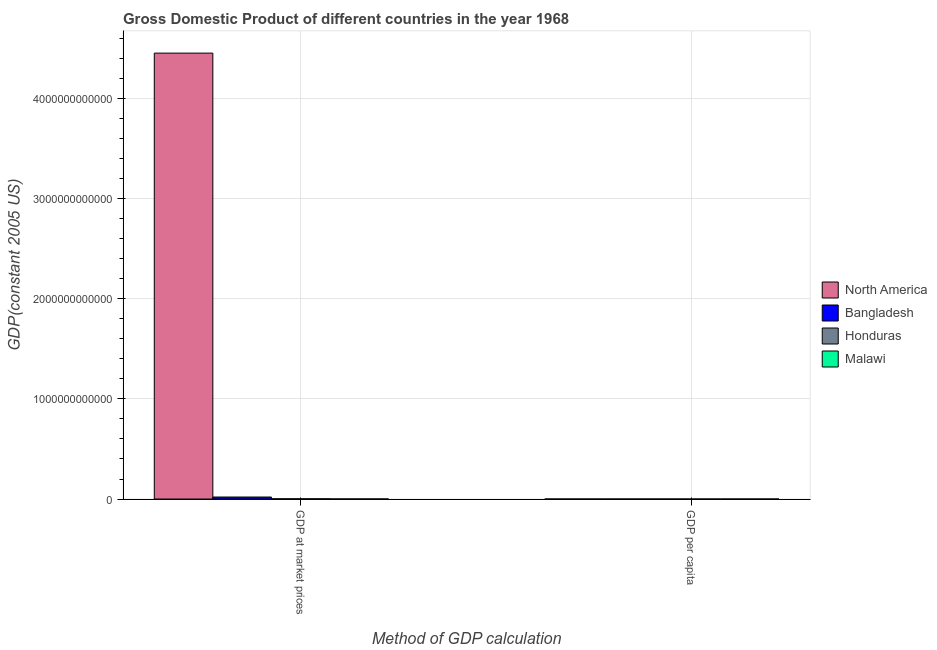How many different coloured bars are there?
Your response must be concise. 4. Are the number of bars on each tick of the X-axis equal?
Your answer should be very brief. Yes. How many bars are there on the 2nd tick from the left?
Your response must be concise. 4. What is the label of the 1st group of bars from the left?
Provide a short and direct response. GDP at market prices. What is the gdp at market prices in Bangladesh?
Your answer should be compact. 2.00e+1. Across all countries, what is the maximum gdp at market prices?
Provide a succinct answer. 4.46e+12. Across all countries, what is the minimum gdp per capita?
Your answer should be very brief. 169.82. In which country was the gdp per capita maximum?
Your response must be concise. North America. In which country was the gdp per capita minimum?
Provide a short and direct response. Malawi. What is the total gdp at market prices in the graph?
Keep it short and to the point. 4.48e+12. What is the difference between the gdp per capita in Malawi and that in North America?
Offer a terse response. -1.99e+04. What is the difference between the gdp at market prices in Bangladesh and the gdp per capita in Honduras?
Offer a terse response. 2.00e+1. What is the average gdp at market prices per country?
Your answer should be compact. 1.12e+12. What is the difference between the gdp per capita and gdp at market prices in North America?
Your answer should be very brief. -4.46e+12. In how many countries, is the gdp at market prices greater than 2400000000000 US$?
Offer a terse response. 1. What is the ratio of the gdp at market prices in Bangladesh to that in Honduras?
Make the answer very short. 8.03. How many bars are there?
Ensure brevity in your answer.  8. Are all the bars in the graph horizontal?
Offer a terse response. No. What is the difference between two consecutive major ticks on the Y-axis?
Give a very brief answer. 1.00e+12. Are the values on the major ticks of Y-axis written in scientific E-notation?
Your answer should be very brief. No. Does the graph contain grids?
Ensure brevity in your answer.  Yes. Where does the legend appear in the graph?
Your response must be concise. Center right. What is the title of the graph?
Give a very brief answer. Gross Domestic Product of different countries in the year 1968. What is the label or title of the X-axis?
Your answer should be compact. Method of GDP calculation. What is the label or title of the Y-axis?
Your answer should be very brief. GDP(constant 2005 US). What is the GDP(constant 2005 US) of North America in GDP at market prices?
Your answer should be compact. 4.46e+12. What is the GDP(constant 2005 US) of Bangladesh in GDP at market prices?
Your response must be concise. 2.00e+1. What is the GDP(constant 2005 US) of Honduras in GDP at market prices?
Ensure brevity in your answer.  2.49e+09. What is the GDP(constant 2005 US) in Malawi in GDP at market prices?
Keep it short and to the point. 7.42e+08. What is the GDP(constant 2005 US) of North America in GDP per capita?
Make the answer very short. 2.01e+04. What is the GDP(constant 2005 US) of Bangladesh in GDP per capita?
Offer a terse response. 324.44. What is the GDP(constant 2005 US) of Honduras in GDP per capita?
Provide a succinct answer. 974.35. What is the GDP(constant 2005 US) of Malawi in GDP per capita?
Offer a terse response. 169.82. Across all Method of GDP calculation, what is the maximum GDP(constant 2005 US) of North America?
Keep it short and to the point. 4.46e+12. Across all Method of GDP calculation, what is the maximum GDP(constant 2005 US) in Bangladesh?
Ensure brevity in your answer.  2.00e+1. Across all Method of GDP calculation, what is the maximum GDP(constant 2005 US) in Honduras?
Your answer should be very brief. 2.49e+09. Across all Method of GDP calculation, what is the maximum GDP(constant 2005 US) in Malawi?
Provide a short and direct response. 7.42e+08. Across all Method of GDP calculation, what is the minimum GDP(constant 2005 US) of North America?
Ensure brevity in your answer.  2.01e+04. Across all Method of GDP calculation, what is the minimum GDP(constant 2005 US) in Bangladesh?
Keep it short and to the point. 324.44. Across all Method of GDP calculation, what is the minimum GDP(constant 2005 US) in Honduras?
Your answer should be compact. 974.35. Across all Method of GDP calculation, what is the minimum GDP(constant 2005 US) in Malawi?
Your response must be concise. 169.82. What is the total GDP(constant 2005 US) in North America in the graph?
Your answer should be very brief. 4.46e+12. What is the total GDP(constant 2005 US) of Bangladesh in the graph?
Your answer should be very brief. 2.00e+1. What is the total GDP(constant 2005 US) in Honduras in the graph?
Offer a very short reply. 2.49e+09. What is the total GDP(constant 2005 US) of Malawi in the graph?
Ensure brevity in your answer.  7.42e+08. What is the difference between the GDP(constant 2005 US) in North America in GDP at market prices and that in GDP per capita?
Keep it short and to the point. 4.46e+12. What is the difference between the GDP(constant 2005 US) in Bangladesh in GDP at market prices and that in GDP per capita?
Your answer should be compact. 2.00e+1. What is the difference between the GDP(constant 2005 US) of Honduras in GDP at market prices and that in GDP per capita?
Offer a very short reply. 2.49e+09. What is the difference between the GDP(constant 2005 US) in Malawi in GDP at market prices and that in GDP per capita?
Make the answer very short. 7.42e+08. What is the difference between the GDP(constant 2005 US) in North America in GDP at market prices and the GDP(constant 2005 US) in Bangladesh in GDP per capita?
Your answer should be very brief. 4.46e+12. What is the difference between the GDP(constant 2005 US) of North America in GDP at market prices and the GDP(constant 2005 US) of Honduras in GDP per capita?
Your response must be concise. 4.46e+12. What is the difference between the GDP(constant 2005 US) of North America in GDP at market prices and the GDP(constant 2005 US) of Malawi in GDP per capita?
Offer a terse response. 4.46e+12. What is the difference between the GDP(constant 2005 US) in Bangladesh in GDP at market prices and the GDP(constant 2005 US) in Honduras in GDP per capita?
Ensure brevity in your answer.  2.00e+1. What is the difference between the GDP(constant 2005 US) in Bangladesh in GDP at market prices and the GDP(constant 2005 US) in Malawi in GDP per capita?
Your answer should be compact. 2.00e+1. What is the difference between the GDP(constant 2005 US) in Honduras in GDP at market prices and the GDP(constant 2005 US) in Malawi in GDP per capita?
Ensure brevity in your answer.  2.49e+09. What is the average GDP(constant 2005 US) in North America per Method of GDP calculation?
Offer a very short reply. 2.23e+12. What is the average GDP(constant 2005 US) of Bangladesh per Method of GDP calculation?
Your answer should be very brief. 9.99e+09. What is the average GDP(constant 2005 US) of Honduras per Method of GDP calculation?
Make the answer very short. 1.24e+09. What is the average GDP(constant 2005 US) of Malawi per Method of GDP calculation?
Provide a succinct answer. 3.71e+08. What is the difference between the GDP(constant 2005 US) of North America and GDP(constant 2005 US) of Bangladesh in GDP at market prices?
Provide a succinct answer. 4.44e+12. What is the difference between the GDP(constant 2005 US) in North America and GDP(constant 2005 US) in Honduras in GDP at market prices?
Give a very brief answer. 4.45e+12. What is the difference between the GDP(constant 2005 US) in North America and GDP(constant 2005 US) in Malawi in GDP at market prices?
Give a very brief answer. 4.45e+12. What is the difference between the GDP(constant 2005 US) of Bangladesh and GDP(constant 2005 US) of Honduras in GDP at market prices?
Your answer should be very brief. 1.75e+1. What is the difference between the GDP(constant 2005 US) in Bangladesh and GDP(constant 2005 US) in Malawi in GDP at market prices?
Provide a succinct answer. 1.92e+1. What is the difference between the GDP(constant 2005 US) of Honduras and GDP(constant 2005 US) of Malawi in GDP at market prices?
Provide a succinct answer. 1.74e+09. What is the difference between the GDP(constant 2005 US) of North America and GDP(constant 2005 US) of Bangladesh in GDP per capita?
Provide a short and direct response. 1.98e+04. What is the difference between the GDP(constant 2005 US) in North America and GDP(constant 2005 US) in Honduras in GDP per capita?
Provide a short and direct response. 1.91e+04. What is the difference between the GDP(constant 2005 US) of North America and GDP(constant 2005 US) of Malawi in GDP per capita?
Keep it short and to the point. 1.99e+04. What is the difference between the GDP(constant 2005 US) of Bangladesh and GDP(constant 2005 US) of Honduras in GDP per capita?
Keep it short and to the point. -649.91. What is the difference between the GDP(constant 2005 US) in Bangladesh and GDP(constant 2005 US) in Malawi in GDP per capita?
Ensure brevity in your answer.  154.62. What is the difference between the GDP(constant 2005 US) of Honduras and GDP(constant 2005 US) of Malawi in GDP per capita?
Your answer should be compact. 804.54. What is the ratio of the GDP(constant 2005 US) in North America in GDP at market prices to that in GDP per capita?
Your answer should be very brief. 2.22e+08. What is the ratio of the GDP(constant 2005 US) in Bangladesh in GDP at market prices to that in GDP per capita?
Ensure brevity in your answer.  6.16e+07. What is the ratio of the GDP(constant 2005 US) of Honduras in GDP at market prices to that in GDP per capita?
Make the answer very short. 2.55e+06. What is the ratio of the GDP(constant 2005 US) in Malawi in GDP at market prices to that in GDP per capita?
Your response must be concise. 4.37e+06. What is the difference between the highest and the second highest GDP(constant 2005 US) in North America?
Keep it short and to the point. 4.46e+12. What is the difference between the highest and the second highest GDP(constant 2005 US) of Bangladesh?
Provide a short and direct response. 2.00e+1. What is the difference between the highest and the second highest GDP(constant 2005 US) in Honduras?
Your response must be concise. 2.49e+09. What is the difference between the highest and the second highest GDP(constant 2005 US) of Malawi?
Provide a short and direct response. 7.42e+08. What is the difference between the highest and the lowest GDP(constant 2005 US) in North America?
Ensure brevity in your answer.  4.46e+12. What is the difference between the highest and the lowest GDP(constant 2005 US) in Bangladesh?
Ensure brevity in your answer.  2.00e+1. What is the difference between the highest and the lowest GDP(constant 2005 US) of Honduras?
Provide a succinct answer. 2.49e+09. What is the difference between the highest and the lowest GDP(constant 2005 US) in Malawi?
Provide a short and direct response. 7.42e+08. 